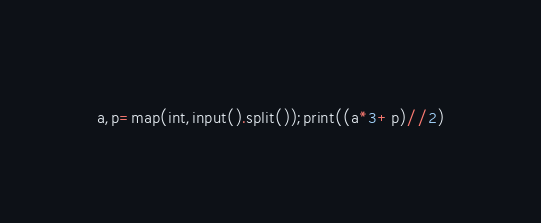<code> <loc_0><loc_0><loc_500><loc_500><_Python_>a,p=map(int,input().split());print((a*3+p)//2)</code> 